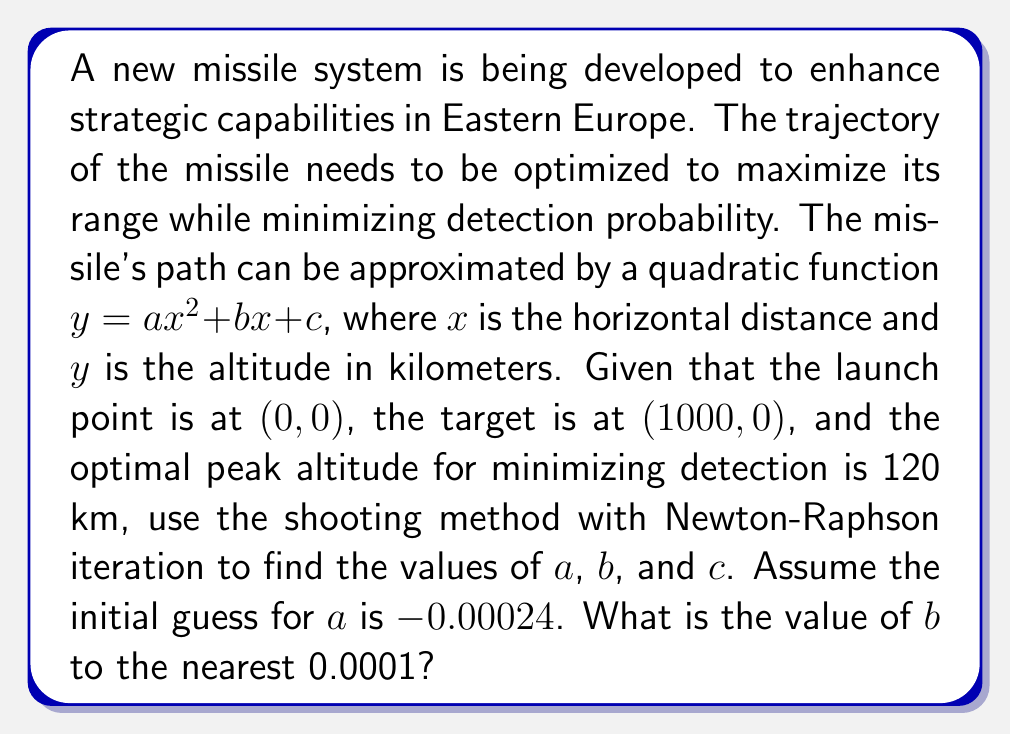Provide a solution to this math problem. To solve this problem, we'll use the shooting method combined with Newton-Raphson iteration. Let's break it down step by step:

1) Given conditions:
   - Launch point: $(0, 0)$
   - Target point: $(1000, 0)$
   - Peak altitude: 120 km

2) The quadratic function: $y = ax^2 + bx + c$

3) Constraints:
   - At $(0, 0)$: $c = 0$
   - At $(1000, 0)$: $a(1000)^2 + 1000b + c = 0$
   - Peak at $x = 500$, $y = 120$: $a(500)^2 + 500b = 120$

4) From the second constraint:
   $a(1000000) + 1000b = 0$
   $b = -1000a$

5) Substituting into the third constraint:
   $a(250000) - 500000a = 120$
   $-250000a = 120$
   $a = -0.00048$

6) Now, let's use Newton-Raphson iteration starting with $a_0 = -0.00024$:

   $f(a) = 250000a + 120$
   $f'(a) = 250000$

   $a_{n+1} = a_n - \frac{f(a_n)}{f'(a_n)}$

   $a_1 = -0.00024 - \frac{250000(-0.00024) + 120}{250000} = -0.00072$
   
   $a_2 = -0.00072 - \frac{250000(-0.00072) + 120}{250000} = -0.00048$

7) The iteration converges at $a = -0.00048$, which matches our analytical solution.

8) Now we can calculate $b$:
   $b = -1000a = -1000(-0.00048) = 0.48$
Answer: $b = 0.4800$ 